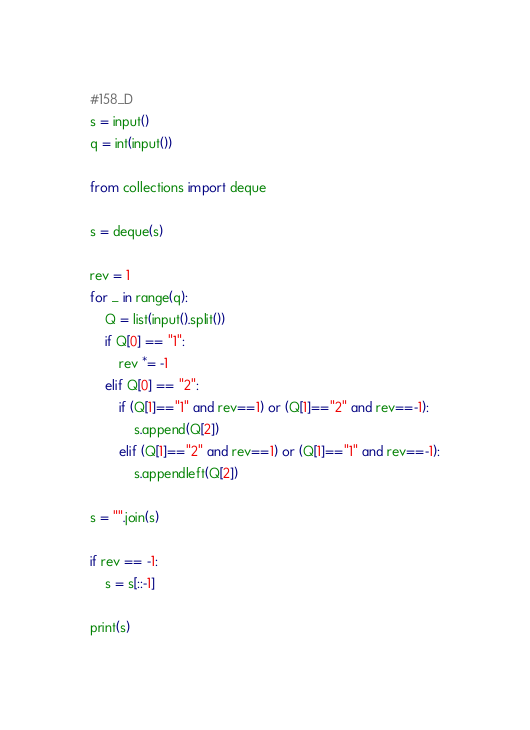<code> <loc_0><loc_0><loc_500><loc_500><_Python_>#158_D
s = input()
q = int(input())

from collections import deque

s = deque(s)

rev = 1
for _ in range(q):
    Q = list(input().split())
    if Q[0] == "1":
        rev *= -1
    elif Q[0] == "2":
        if (Q[1]=="1" and rev==1) or (Q[1]=="2" and rev==-1):
            s.append(Q[2])
        elif (Q[1]=="2" and rev==1) or (Q[1]=="1" and rev==-1):
            s.appendleft(Q[2])
            
s = "".join(s)
            
if rev == -1:
    s = s[::-1]

print(s)</code> 